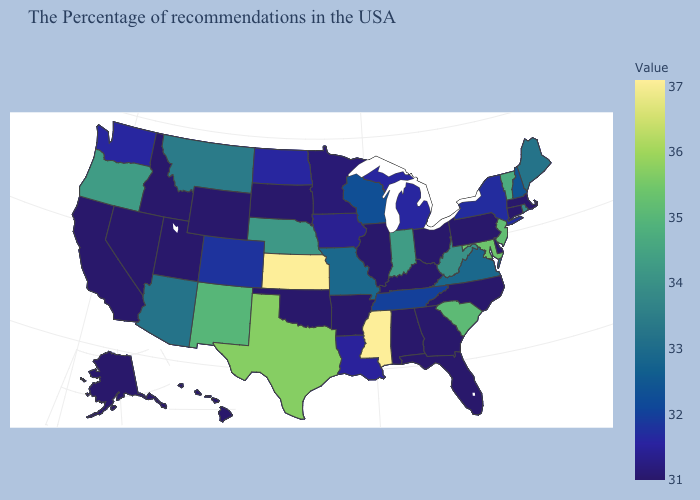Does Georgia have the highest value in the South?
Concise answer only. No. Among the states that border Delaware , which have the lowest value?
Keep it brief. Pennsylvania. Does Tennessee have the highest value in the South?
Be succinct. No. 